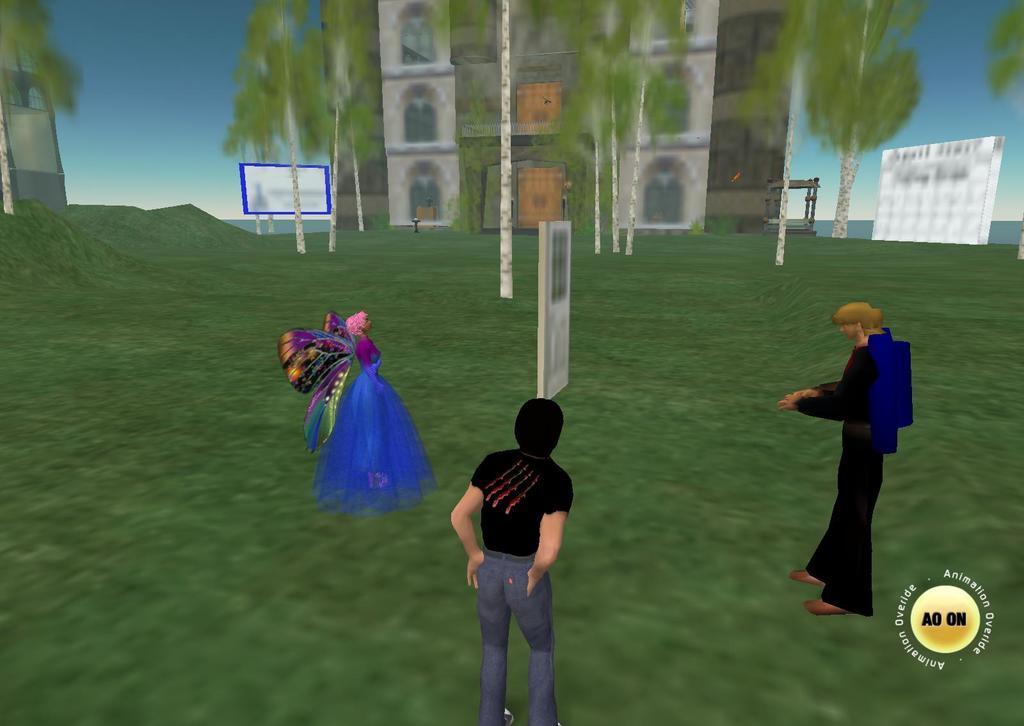Please provide a concise description of this image. In the image we can see an animated picture, here we can see two men and a woman standing, wearing clothes. Here we can see the grass, the building, trees, boards and the sky. 